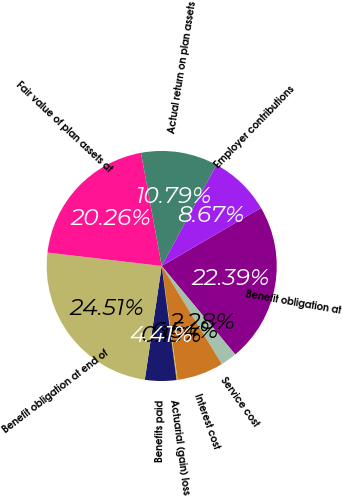Convert chart. <chart><loc_0><loc_0><loc_500><loc_500><pie_chart><fcel>Benefit obligation at<fcel>Service cost<fcel>Interest cost<fcel>Actuarial (gain) loss<fcel>Benefits paid<fcel>Benefit obligation at end of<fcel>Fair value of plan assets at<fcel>Actual return on plan assets<fcel>Employer contributions<nl><fcel>22.39%<fcel>2.28%<fcel>6.54%<fcel>0.15%<fcel>4.41%<fcel>24.51%<fcel>20.26%<fcel>10.79%<fcel>8.67%<nl></chart> 